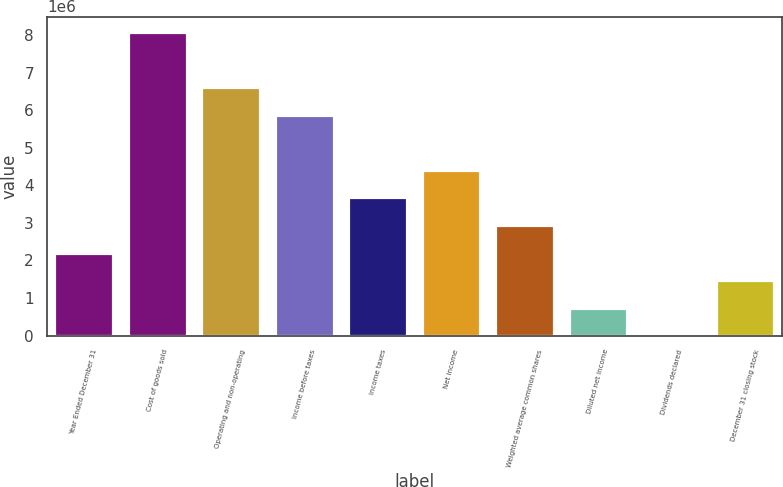Convert chart to OTSL. <chart><loc_0><loc_0><loc_500><loc_500><bar_chart><fcel>Year Ended December 31<fcel>Cost of goods sold<fcel>Operating and non-operating<fcel>Income before taxes<fcel>Income taxes<fcel>Net income<fcel>Weighted average common shares<fcel>Diluted net income<fcel>Dividends declared<fcel>December 31 closing stock<nl><fcel>2.20604e+06<fcel>8.08879e+06<fcel>6.6181e+06<fcel>5.88276e+06<fcel>3.67672e+06<fcel>4.41207e+06<fcel>2.94138e+06<fcel>735346<fcel>1.35<fcel>1.47069e+06<nl></chart> 